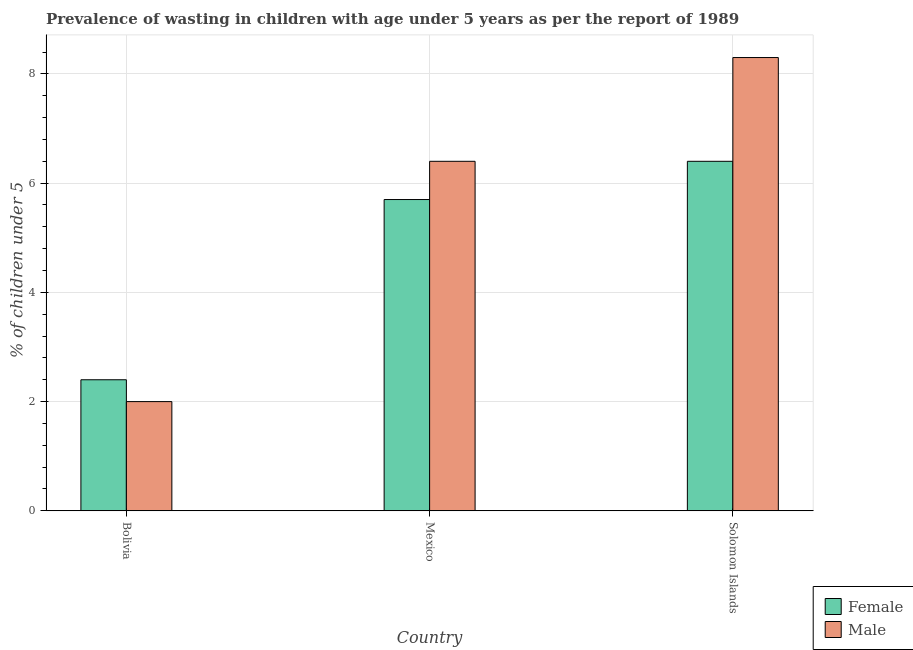Are the number of bars per tick equal to the number of legend labels?
Make the answer very short. Yes. Are the number of bars on each tick of the X-axis equal?
Provide a succinct answer. Yes. What is the label of the 2nd group of bars from the left?
Give a very brief answer. Mexico. In how many cases, is the number of bars for a given country not equal to the number of legend labels?
Provide a short and direct response. 0. What is the percentage of undernourished male children in Solomon Islands?
Provide a succinct answer. 8.3. Across all countries, what is the maximum percentage of undernourished male children?
Keep it short and to the point. 8.3. In which country was the percentage of undernourished male children maximum?
Keep it short and to the point. Solomon Islands. What is the total percentage of undernourished female children in the graph?
Your answer should be compact. 14.5. What is the difference between the percentage of undernourished female children in Mexico and that in Solomon Islands?
Your answer should be very brief. -0.7. What is the difference between the percentage of undernourished male children in Solomon Islands and the percentage of undernourished female children in Bolivia?
Your answer should be compact. 5.9. What is the average percentage of undernourished female children per country?
Keep it short and to the point. 4.83. What is the difference between the percentage of undernourished female children and percentage of undernourished male children in Bolivia?
Provide a short and direct response. 0.4. In how many countries, is the percentage of undernourished female children greater than 1.2000000000000002 %?
Make the answer very short. 3. What is the ratio of the percentage of undernourished female children in Bolivia to that in Solomon Islands?
Provide a succinct answer. 0.38. Is the percentage of undernourished female children in Bolivia less than that in Solomon Islands?
Your response must be concise. Yes. Is the difference between the percentage of undernourished female children in Bolivia and Mexico greater than the difference between the percentage of undernourished male children in Bolivia and Mexico?
Offer a terse response. Yes. What is the difference between the highest and the second highest percentage of undernourished male children?
Ensure brevity in your answer.  1.9. What is the difference between the highest and the lowest percentage of undernourished male children?
Ensure brevity in your answer.  6.3. What does the 2nd bar from the left in Mexico represents?
Provide a short and direct response. Male. Are all the bars in the graph horizontal?
Your answer should be compact. No. How many countries are there in the graph?
Make the answer very short. 3. What is the difference between two consecutive major ticks on the Y-axis?
Keep it short and to the point. 2. How many legend labels are there?
Provide a short and direct response. 2. How are the legend labels stacked?
Your answer should be compact. Vertical. What is the title of the graph?
Offer a very short reply. Prevalence of wasting in children with age under 5 years as per the report of 1989. Does "Personal remittances" appear as one of the legend labels in the graph?
Provide a succinct answer. No. What is the label or title of the X-axis?
Your response must be concise. Country. What is the label or title of the Y-axis?
Offer a very short reply.  % of children under 5. What is the  % of children under 5 in Female in Bolivia?
Provide a short and direct response. 2.4. What is the  % of children under 5 in Female in Mexico?
Your response must be concise. 5.7. What is the  % of children under 5 of Male in Mexico?
Give a very brief answer. 6.4. What is the  % of children under 5 in Female in Solomon Islands?
Keep it short and to the point. 6.4. What is the  % of children under 5 in Male in Solomon Islands?
Give a very brief answer. 8.3. Across all countries, what is the maximum  % of children under 5 of Female?
Make the answer very short. 6.4. Across all countries, what is the maximum  % of children under 5 of Male?
Your answer should be very brief. 8.3. Across all countries, what is the minimum  % of children under 5 of Female?
Offer a very short reply. 2.4. What is the difference between the  % of children under 5 in Female in Bolivia and that in Mexico?
Give a very brief answer. -3.3. What is the difference between the  % of children under 5 in Female in Bolivia and that in Solomon Islands?
Provide a short and direct response. -4. What is the difference between the  % of children under 5 of Male in Mexico and that in Solomon Islands?
Provide a short and direct response. -1.9. What is the difference between the  % of children under 5 of Female in Bolivia and the  % of children under 5 of Male in Mexico?
Offer a very short reply. -4. What is the average  % of children under 5 in Female per country?
Your answer should be compact. 4.83. What is the average  % of children under 5 in Male per country?
Make the answer very short. 5.57. What is the difference between the  % of children under 5 in Female and  % of children under 5 in Male in Solomon Islands?
Provide a succinct answer. -1.9. What is the ratio of the  % of children under 5 in Female in Bolivia to that in Mexico?
Ensure brevity in your answer.  0.42. What is the ratio of the  % of children under 5 of Male in Bolivia to that in Mexico?
Give a very brief answer. 0.31. What is the ratio of the  % of children under 5 of Male in Bolivia to that in Solomon Islands?
Make the answer very short. 0.24. What is the ratio of the  % of children under 5 of Female in Mexico to that in Solomon Islands?
Give a very brief answer. 0.89. What is the ratio of the  % of children under 5 of Male in Mexico to that in Solomon Islands?
Offer a terse response. 0.77. What is the difference between the highest and the second highest  % of children under 5 in Male?
Provide a short and direct response. 1.9. 